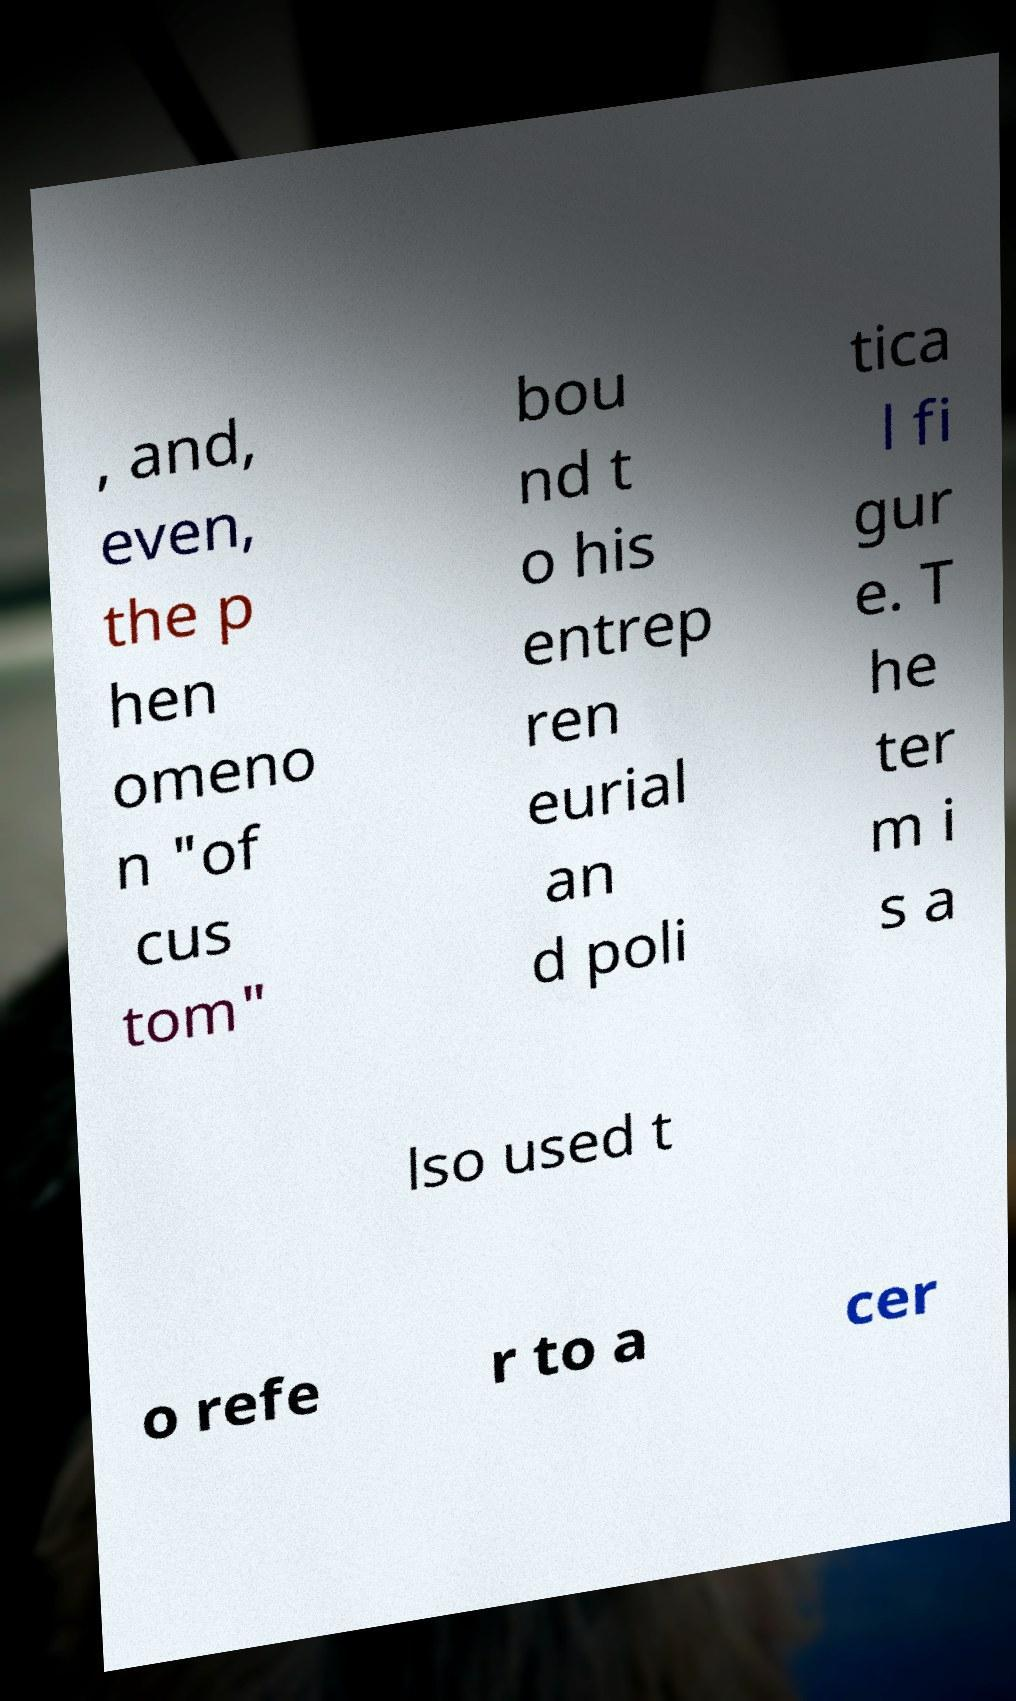There's text embedded in this image that I need extracted. Can you transcribe it verbatim? , and, even, the p hen omeno n "of cus tom" bou nd t o his entrep ren eurial an d poli tica l fi gur e. T he ter m i s a lso used t o refe r to a cer 